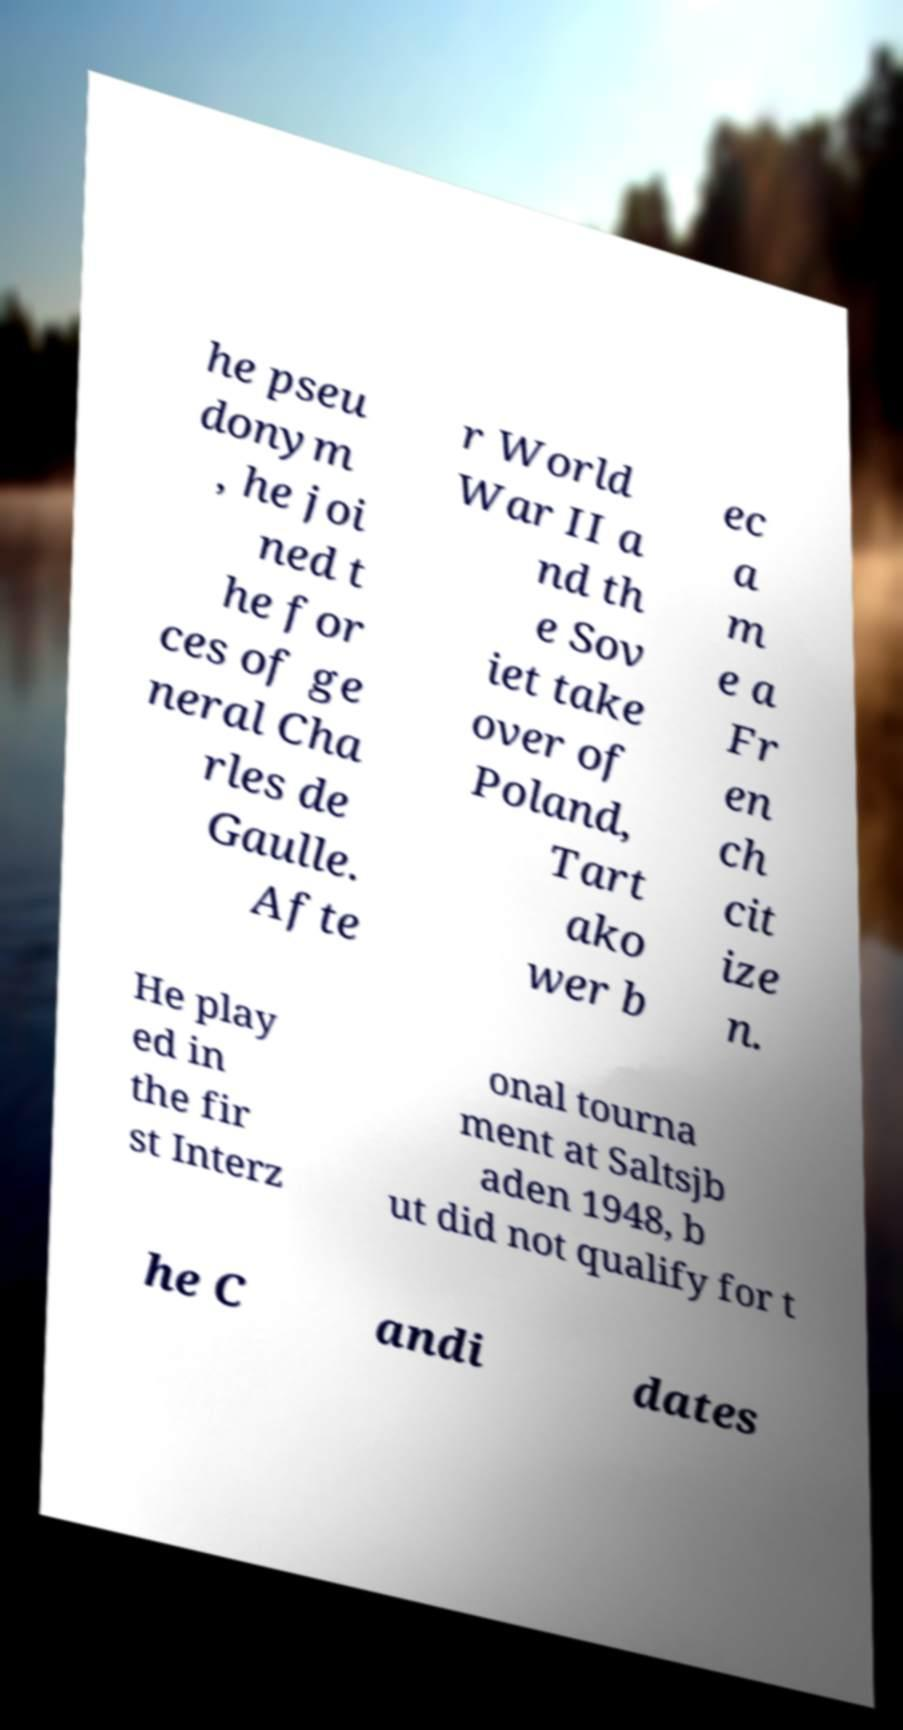Please read and relay the text visible in this image. What does it say? he pseu donym , he joi ned t he for ces of ge neral Cha rles de Gaulle. Afte r World War II a nd th e Sov iet take over of Poland, Tart ako wer b ec a m e a Fr en ch cit ize n. He play ed in the fir st Interz onal tourna ment at Saltsjb aden 1948, b ut did not qualify for t he C andi dates 